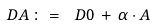Convert formula to latex. <formula><loc_0><loc_0><loc_500><loc_500>\ D A \, \colon = \, \ D { 0 } \, + \, \alpha \cdot A</formula> 